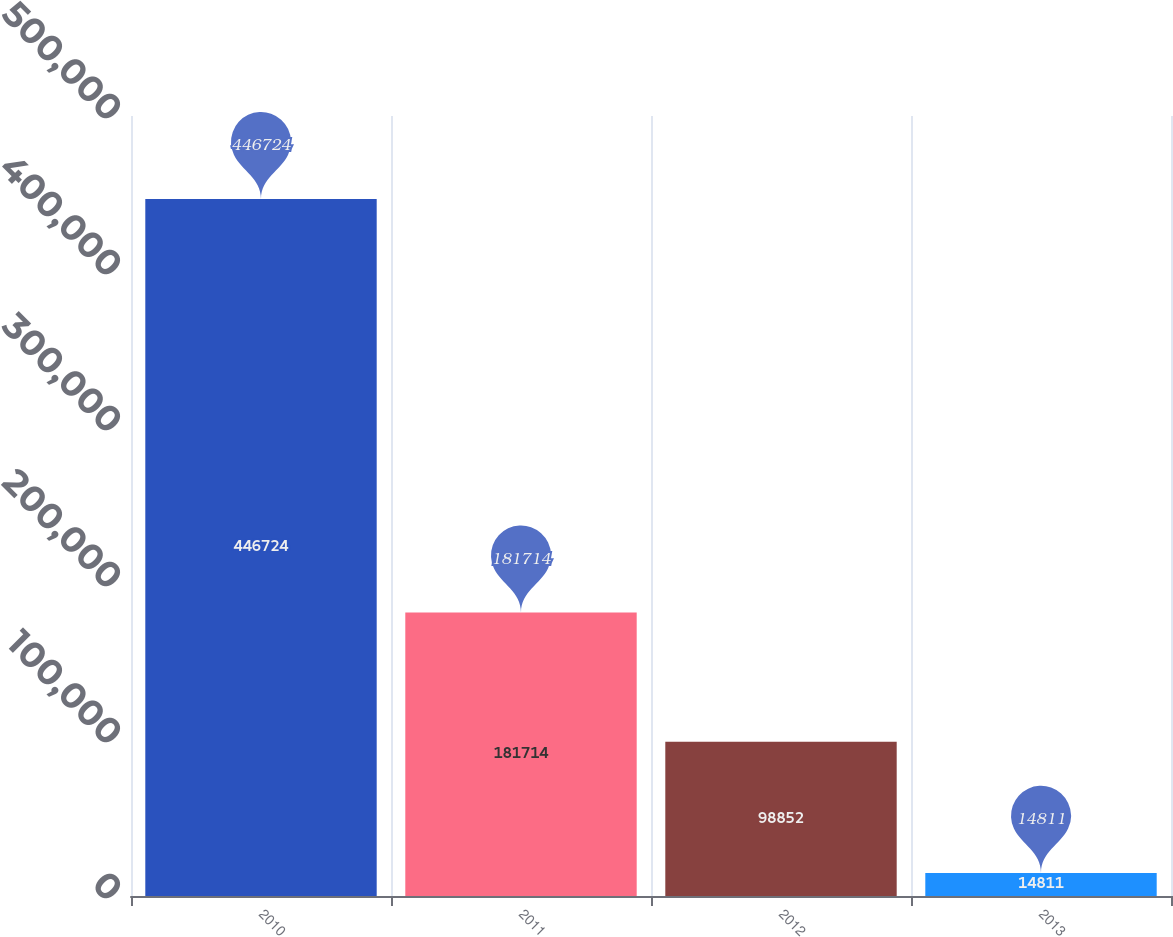<chart> <loc_0><loc_0><loc_500><loc_500><bar_chart><fcel>2010<fcel>2011<fcel>2012<fcel>2013<nl><fcel>446724<fcel>181714<fcel>98852<fcel>14811<nl></chart> 